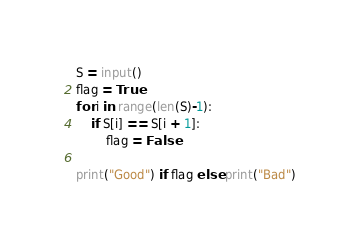<code> <loc_0><loc_0><loc_500><loc_500><_Python_>S = input()
flag = True
for i in range(len(S)-1):
    if S[i] == S[i + 1]:
        flag = False

print("Good") if flag else print("Bad")</code> 